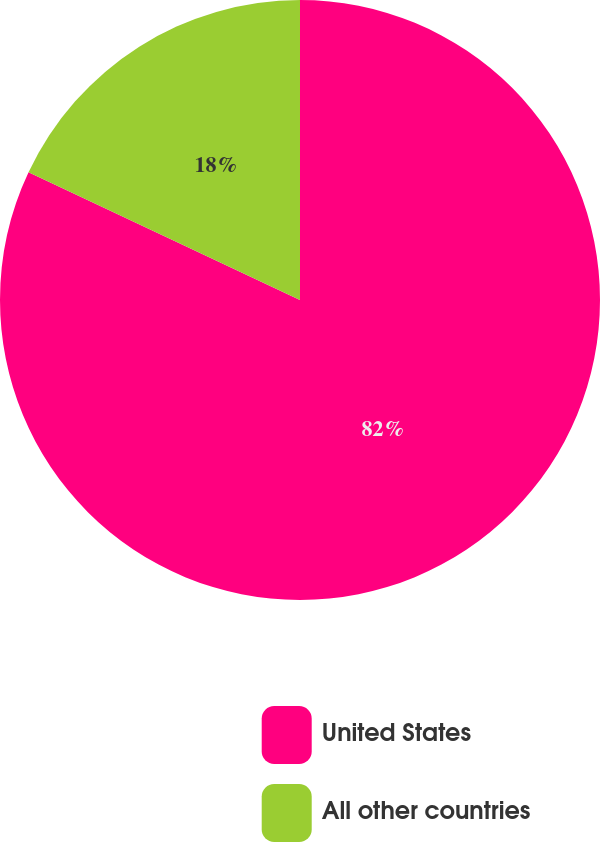<chart> <loc_0><loc_0><loc_500><loc_500><pie_chart><fcel>United States<fcel>All other countries<nl><fcel>82.0%<fcel>18.0%<nl></chart> 